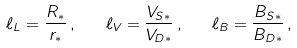<formula> <loc_0><loc_0><loc_500><loc_500>\ell _ { L } = \frac { R _ { * } } { r _ { * } } \, , \quad \ell _ { V } = \frac { V _ { S * } } { V _ { D * } } \, , \quad \ell _ { B } = \frac { B _ { S * } } { B _ { D * } } \, ,</formula> 